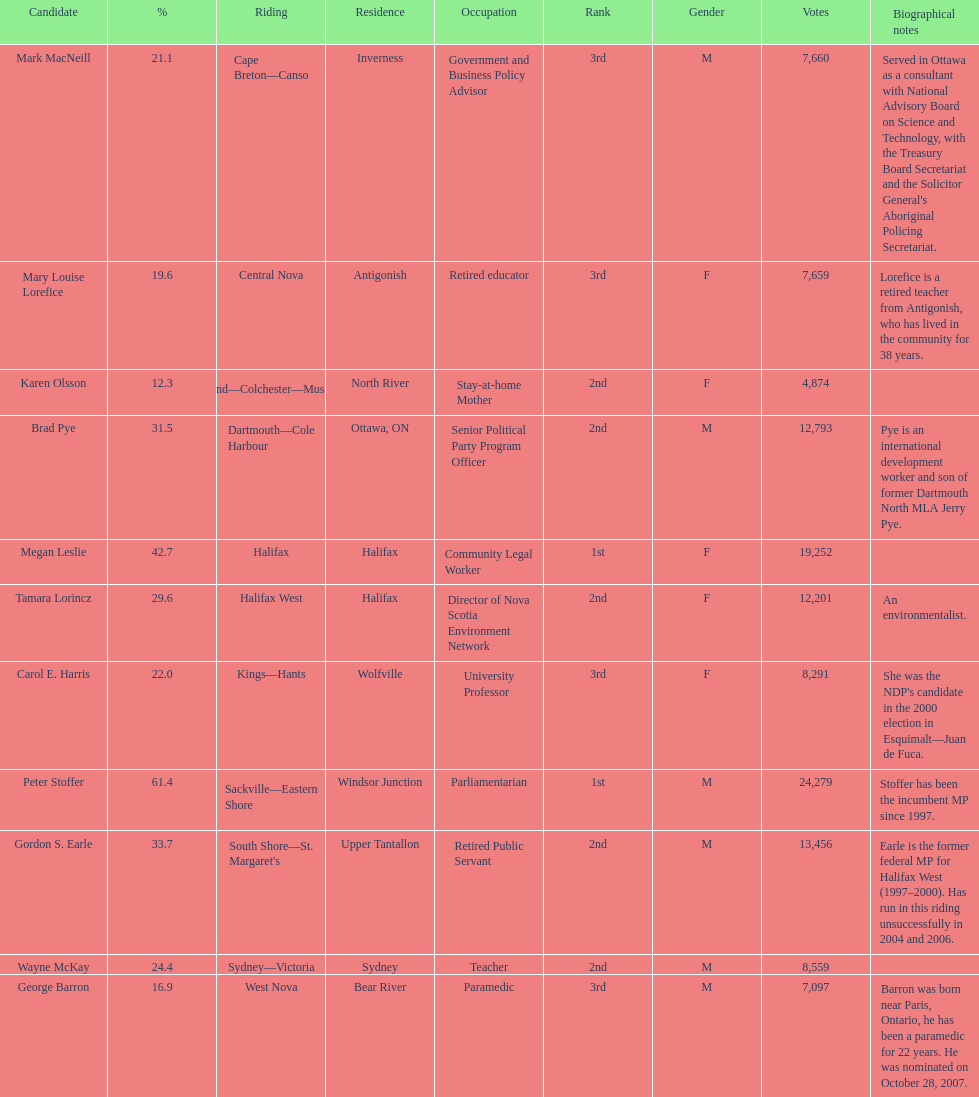Who are all the candidates? Mark MacNeill, Mary Louise Lorefice, Karen Olsson, Brad Pye, Megan Leslie, Tamara Lorincz, Carol E. Harris, Peter Stoffer, Gordon S. Earle, Wayne McKay, George Barron. How many votes did they receive? 7,660, 7,659, 4,874, 12,793, 19,252, 12,201, 8,291, 24,279, 13,456, 8,559, 7,097. And of those, how many were for megan leslie? 19,252. 